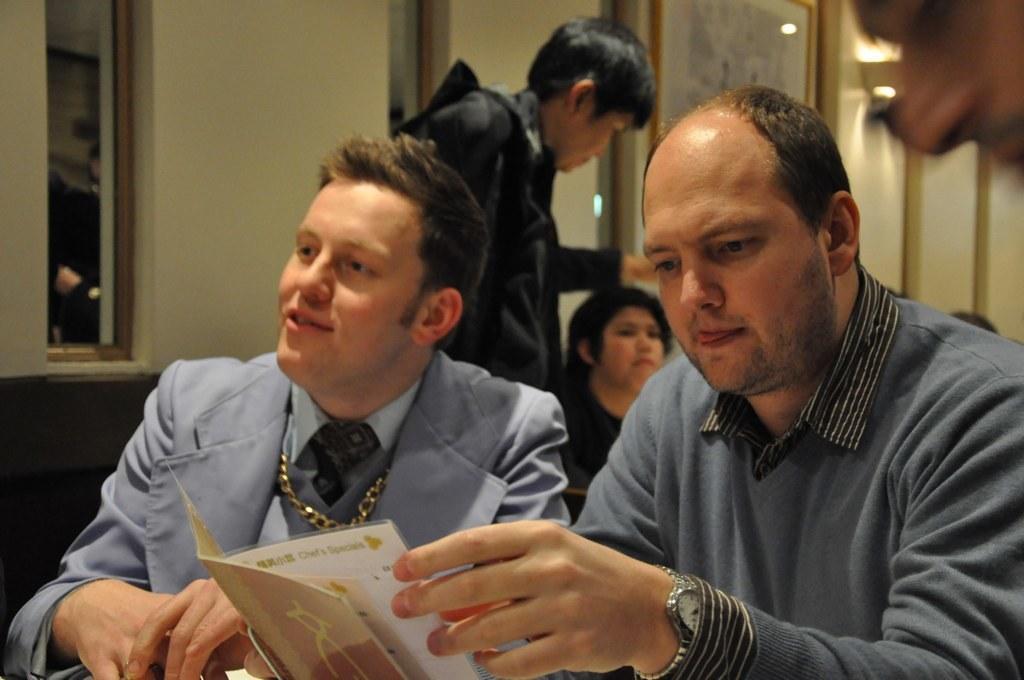Describe this image in one or two sentences. In the image there are two men in the foreground and behind them there are other people, in the background there is a wall and there is a photo frame attached to the wall. 